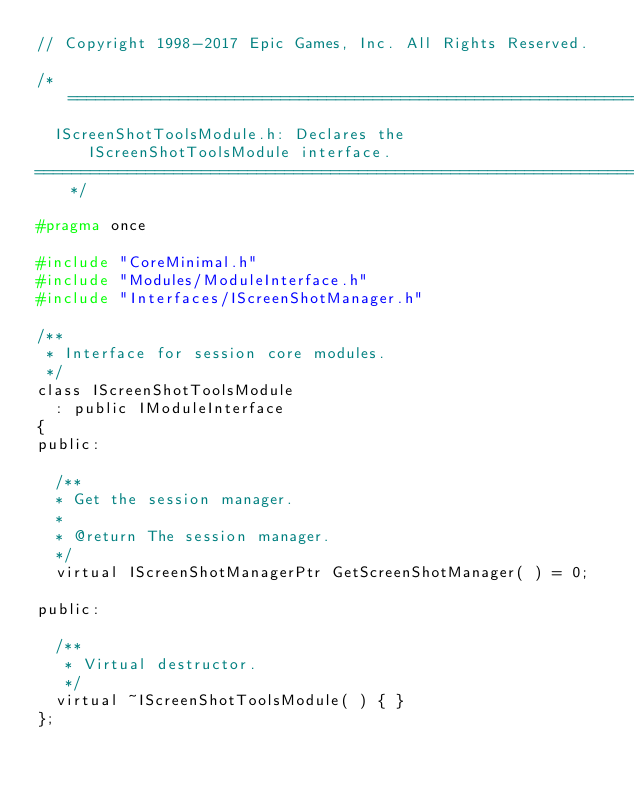Convert code to text. <code><loc_0><loc_0><loc_500><loc_500><_C_>// Copyright 1998-2017 Epic Games, Inc. All Rights Reserved.

/*=============================================================================
	IScreenShotToolsModule.h: Declares the IScreenShotToolsModule interface.
=============================================================================*/

#pragma once

#include "CoreMinimal.h"
#include "Modules/ModuleInterface.h"
#include "Interfaces/IScreenShotManager.h"

/**
 * Interface for session core modules.
 */
class IScreenShotToolsModule
	: public IModuleInterface
{
public:

	/**
	* Get the session manager.
	*
	* @return The session manager.
	*/
	virtual IScreenShotManagerPtr GetScreenShotManager( ) = 0;

public:

	/**
	 * Virtual destructor.
	 */
	virtual ~IScreenShotToolsModule( ) { }
};
</code> 